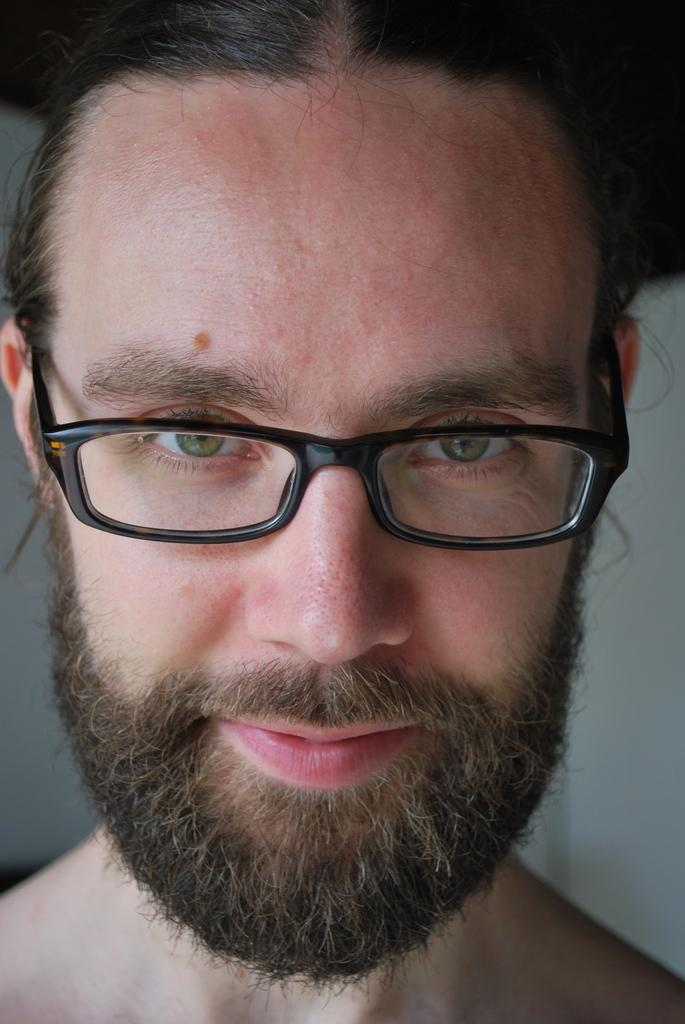What is the main subject of the image? The main subject of the image is a man. What is the man wearing in the image? The man is wearing spectacles in the image. Can you describe the background of the image? The background of the man is blurred in the image. What level of experience does the man have with smelling flowers in the image? There is no indication in the image of the man's experience with smelling flowers, as the image only shows him wearing spectacles with a blurred background. 